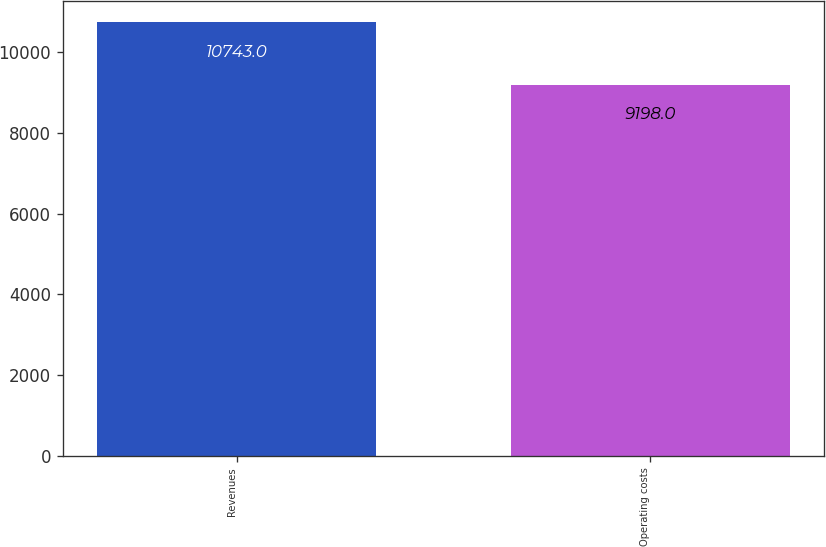Convert chart to OTSL. <chart><loc_0><loc_0><loc_500><loc_500><bar_chart><fcel>Revenues<fcel>Operating costs<nl><fcel>10743<fcel>9198<nl></chart> 